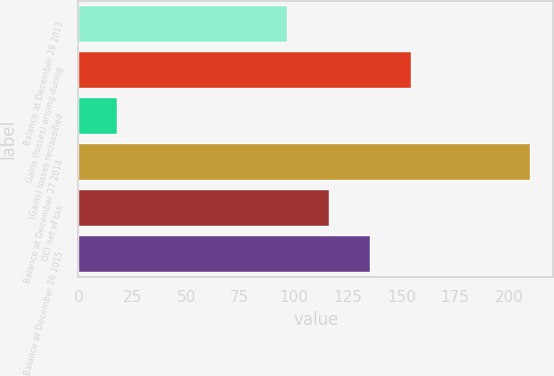Convert chart to OTSL. <chart><loc_0><loc_0><loc_500><loc_500><bar_chart><fcel>Balance at December 28 2013<fcel>Gains (losses) arising during<fcel>(Gains) losses reclassified<fcel>Balance at December 27 2014<fcel>OCI net of tax<fcel>Balance at December 26 2015<nl><fcel>97<fcel>154.6<fcel>18<fcel>210<fcel>116.2<fcel>135.4<nl></chart> 